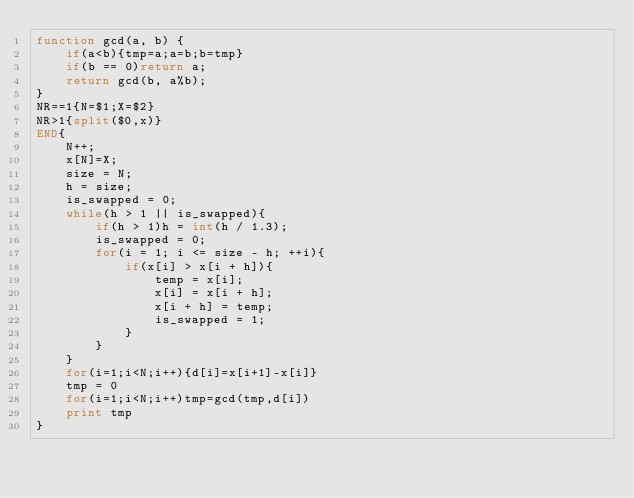Convert code to text. <code><loc_0><loc_0><loc_500><loc_500><_Awk_>function gcd(a, b) {
    if(a<b){tmp=a;a=b;b=tmp}
    if(b == 0)return a;
    return gcd(b, a%b);
}
NR==1{N=$1;X=$2}
NR>1{split($0,x)}
END{
	N++;
	x[N]=X;
    size = N;
	h = size;
    is_swapped = 0;
    while(h > 1 || is_swapped){
        if(h > 1)h = int(h / 1.3);
        is_swapped = 0;
        for(i = 1; i <= size - h; ++i){
            if(x[i] > x[i + h]){
                temp = x[i];
                x[i] = x[i + h];
                x[i + h] = temp;
                is_swapped = 1;
            }
        }
    }
    for(i=1;i<N;i++){d[i]=x[i+1]-x[i]}
    tmp = 0
    for(i=1;i<N;i++)tmp=gcd(tmp,d[i])
    print tmp
}</code> 